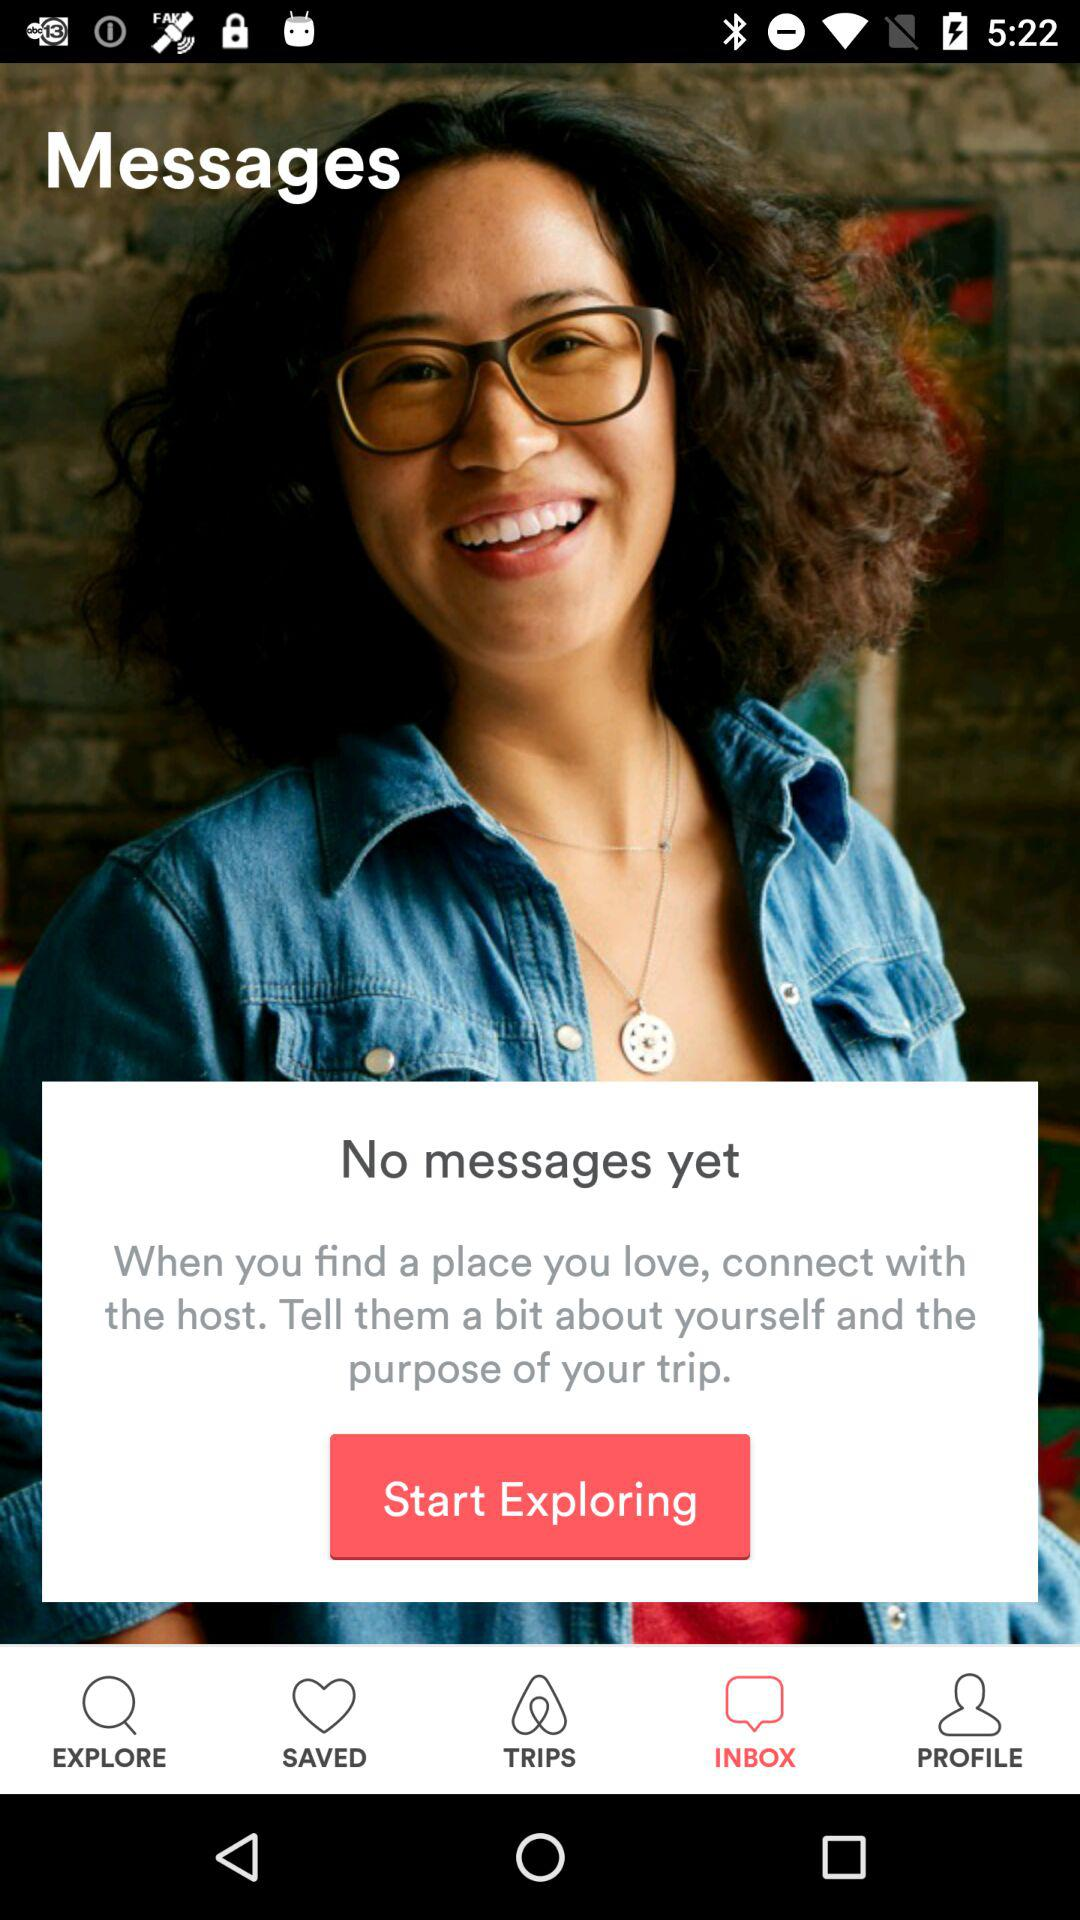What is the selected tab? The selected tab is "INBOX". 